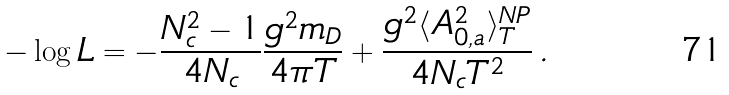Convert formula to latex. <formula><loc_0><loc_0><loc_500><loc_500>- \log L = - \frac { N _ { c } ^ { 2 } - 1 } { 4 N _ { c } } \frac { g ^ { 2 } m _ { D } } { 4 \pi T } + \frac { g ^ { 2 } \langle A _ { 0 , a } ^ { 2 } \rangle _ { T } ^ { N P } } { 4 N _ { c } T ^ { 2 } } \, .</formula> 